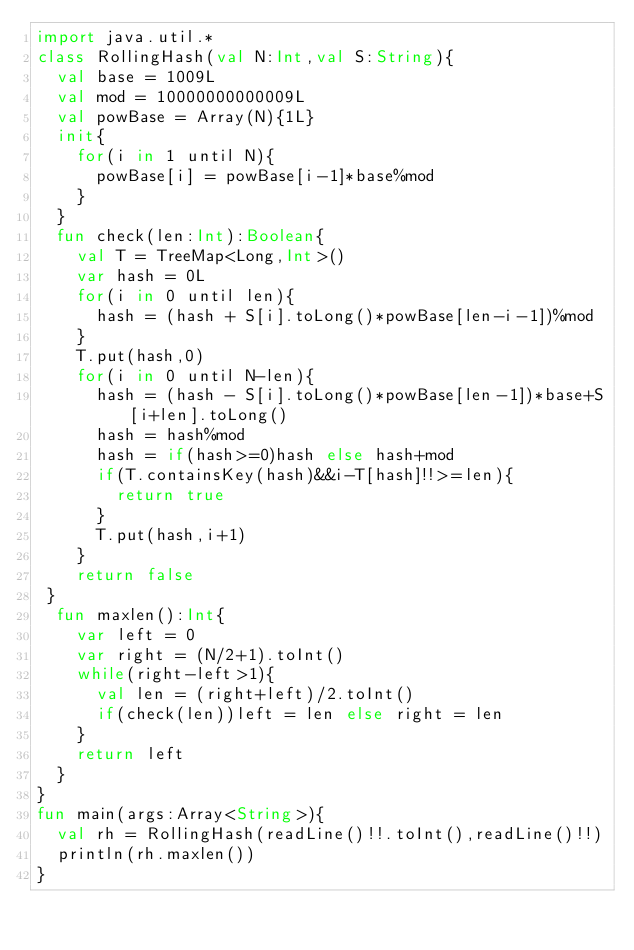Convert code to text. <code><loc_0><loc_0><loc_500><loc_500><_Kotlin_>import java.util.*
class RollingHash(val N:Int,val S:String){
  val base = 1009L
  val mod = 10000000000009L
  val powBase = Array(N){1L}
  init{
    for(i in 1 until N){
      powBase[i] = powBase[i-1]*base%mod
    }
  }
  fun check(len:Int):Boolean{
    val T = TreeMap<Long,Int>()
    var hash = 0L
    for(i in 0 until len){
      hash = (hash + S[i].toLong()*powBase[len-i-1])%mod
    }
    T.put(hash,0)
    for(i in 0 until N-len){
      hash = (hash - S[i].toLong()*powBase[len-1])*base+S[i+len].toLong()
      hash = hash%mod
      hash = if(hash>=0)hash else hash+mod
      if(T.containsKey(hash)&&i-T[hash]!!>=len){
        return true
      }
      T.put(hash,i+1)
    }
    return false
 }
  fun maxlen():Int{
    var left = 0
    var right = (N/2+1).toInt()
    while(right-left>1){
      val len = (right+left)/2.toInt()
      if(check(len))left = len else right = len
    }
    return left
  }
}
fun main(args:Array<String>){
  val rh = RollingHash(readLine()!!.toInt(),readLine()!!)
  println(rh.maxlen())
}
</code> 